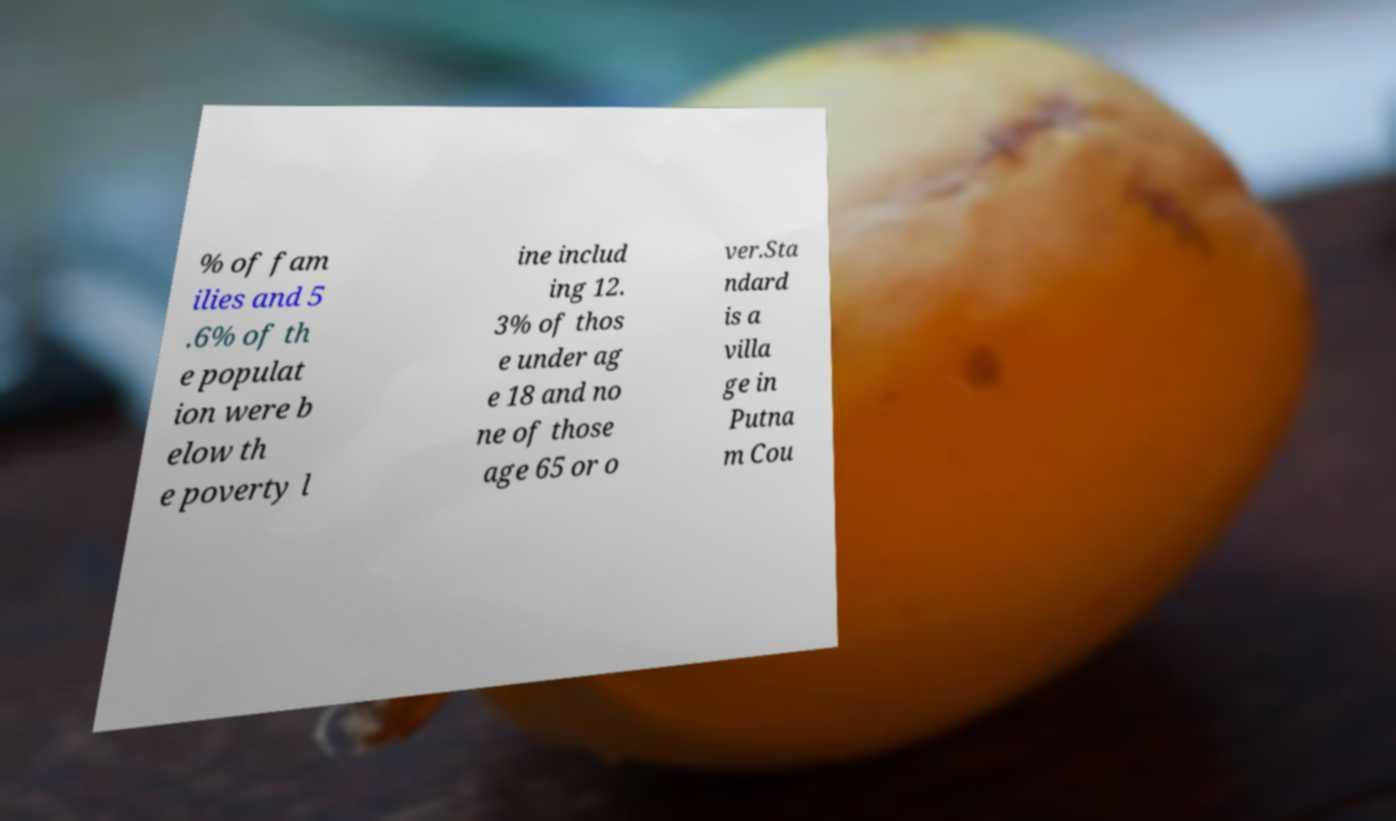What messages or text are displayed in this image? I need them in a readable, typed format. % of fam ilies and 5 .6% of th e populat ion were b elow th e poverty l ine includ ing 12. 3% of thos e under ag e 18 and no ne of those age 65 or o ver.Sta ndard is a villa ge in Putna m Cou 